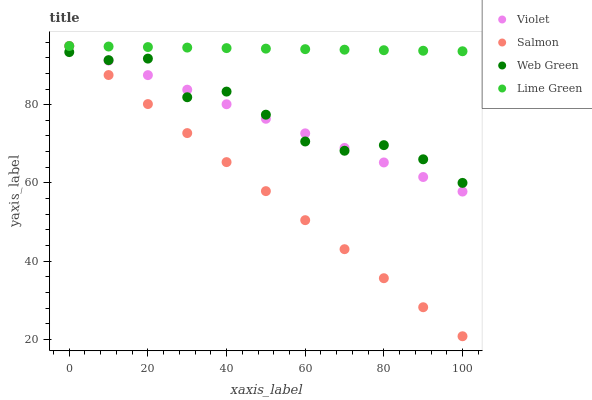Does Salmon have the minimum area under the curve?
Answer yes or no. Yes. Does Lime Green have the maximum area under the curve?
Answer yes or no. Yes. Does Web Green have the minimum area under the curve?
Answer yes or no. No. Does Web Green have the maximum area under the curve?
Answer yes or no. No. Is Violet the smoothest?
Answer yes or no. Yes. Is Web Green the roughest?
Answer yes or no. Yes. Is Salmon the smoothest?
Answer yes or no. No. Is Salmon the roughest?
Answer yes or no. No. Does Salmon have the lowest value?
Answer yes or no. Yes. Does Web Green have the lowest value?
Answer yes or no. No. Does Violet have the highest value?
Answer yes or no. Yes. Does Web Green have the highest value?
Answer yes or no. No. Is Web Green less than Lime Green?
Answer yes or no. Yes. Is Lime Green greater than Web Green?
Answer yes or no. Yes. Does Salmon intersect Violet?
Answer yes or no. Yes. Is Salmon less than Violet?
Answer yes or no. No. Is Salmon greater than Violet?
Answer yes or no. No. Does Web Green intersect Lime Green?
Answer yes or no. No. 